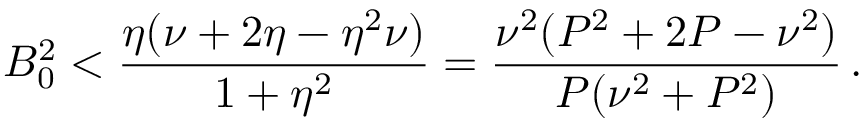Convert formula to latex. <formula><loc_0><loc_0><loc_500><loc_500>B _ { 0 } ^ { 2 } < \frac { \eta ( \nu + 2 \eta - \eta ^ { 2 } \nu ) } { 1 + \eta ^ { 2 } } = \frac { \nu ^ { 2 } ( P ^ { 2 } + 2 P - \nu ^ { 2 } ) } { P ( \nu ^ { 2 } + P ^ { 2 } ) } \, .</formula> 